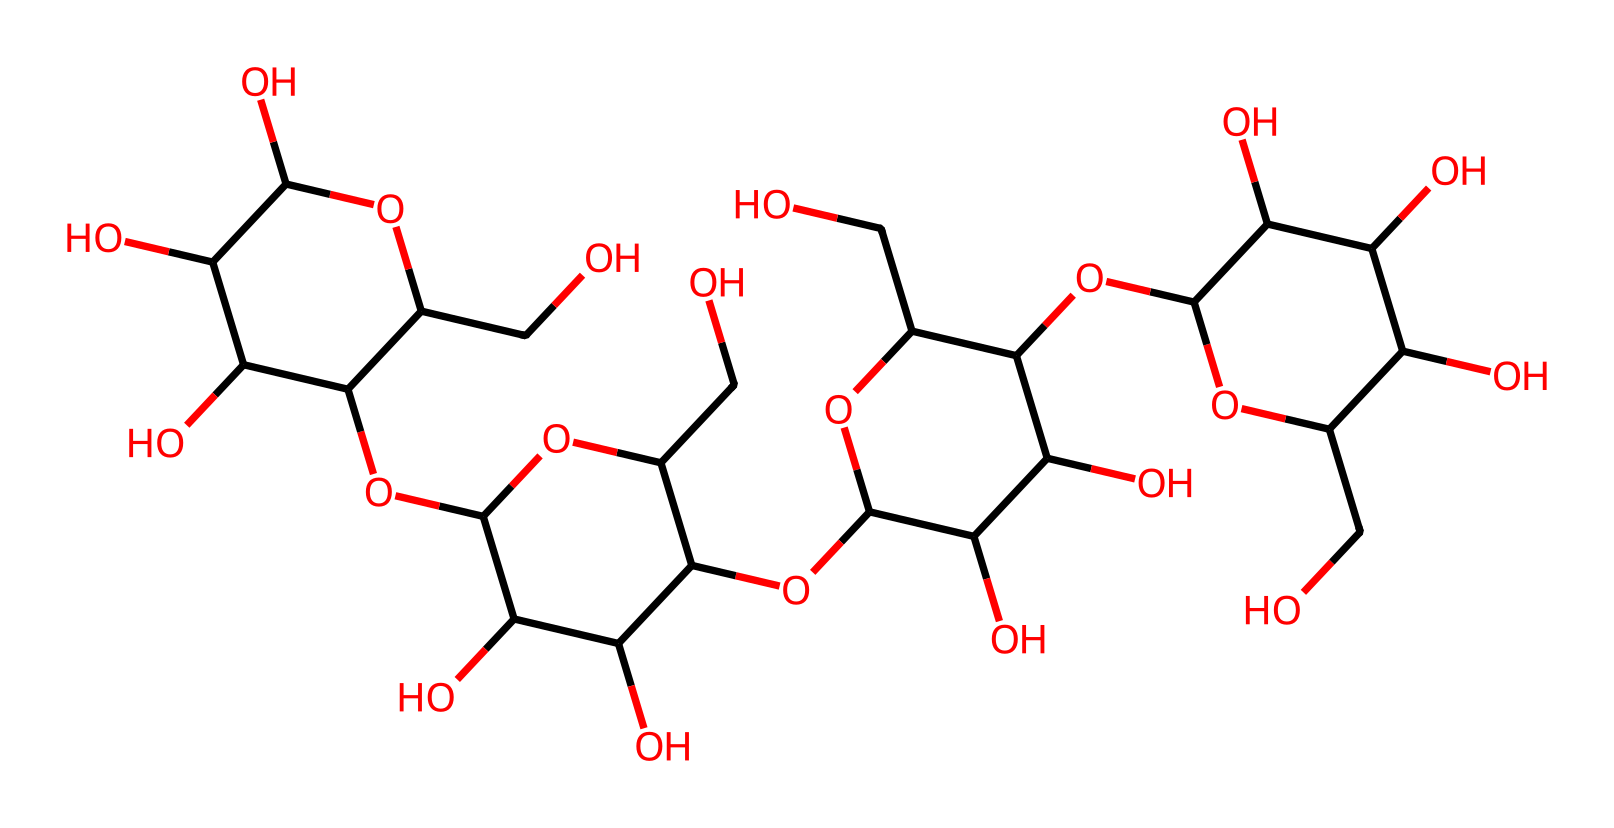What is the molecular formula of the compound represented by the SMILES? To determine the molecular formula, we need to count the number of each type of atom present in the SMILES string. By analyzing the SMILES, we can identify that there are multiple carbon (C), hydrogen (H), and oxygen (O) atoms. A full count reveals a total of 6 carbon atoms, 10 hydrogen atoms, and 5 oxygen atoms, leading to the molecular formula C6H10O5.
Answer: C6H10O5 How many hydroxyl (-OH) groups are present in the structural representation? To count the hydroxyl groups in the chemical structure, we look for the -OH connections throughout the structure. The SMILES indicates many hydroxyl groups, which connect to the carbon backbone. By assessing the structure further, we can enumerate a total of 5 -OH groups in the entire chemical structure.
Answer: 5 What is the primary functional group in this chemical structure? The primary functional group refers to the most prominent groups impacting the chemical’s properties. From the SMILES structure, several -OH groups are observed, indicating that the compound indeed features alcohols as a primary functional group, which characterizes cellulose fibers.
Answer: alcohols How does the structure contribute to the solubility of cellulose in water? Understanding the solubility relates to the presence of hydroxyl groups. The numerous -OH functional groups present in the cellulose structure enhance hydrogen bonding with water molecules, thus making cellulose generally insoluble. The presence of excessive hydroxyl groups leads to strong interactions with polar solvents like water.
Answer: insoluble What is the characteristic repeating unit in the cellulose structure? The characteristic repeating unit, known as the monomer, in cellulose is derived from the glucose units forming the polysaccharide. Each unit comprises a ring structure with hydroxyl groups, repeating to create the cellulose polymer chain shown in the SMILES. Hence, the repeating unit is glucose.
Answer: glucose 